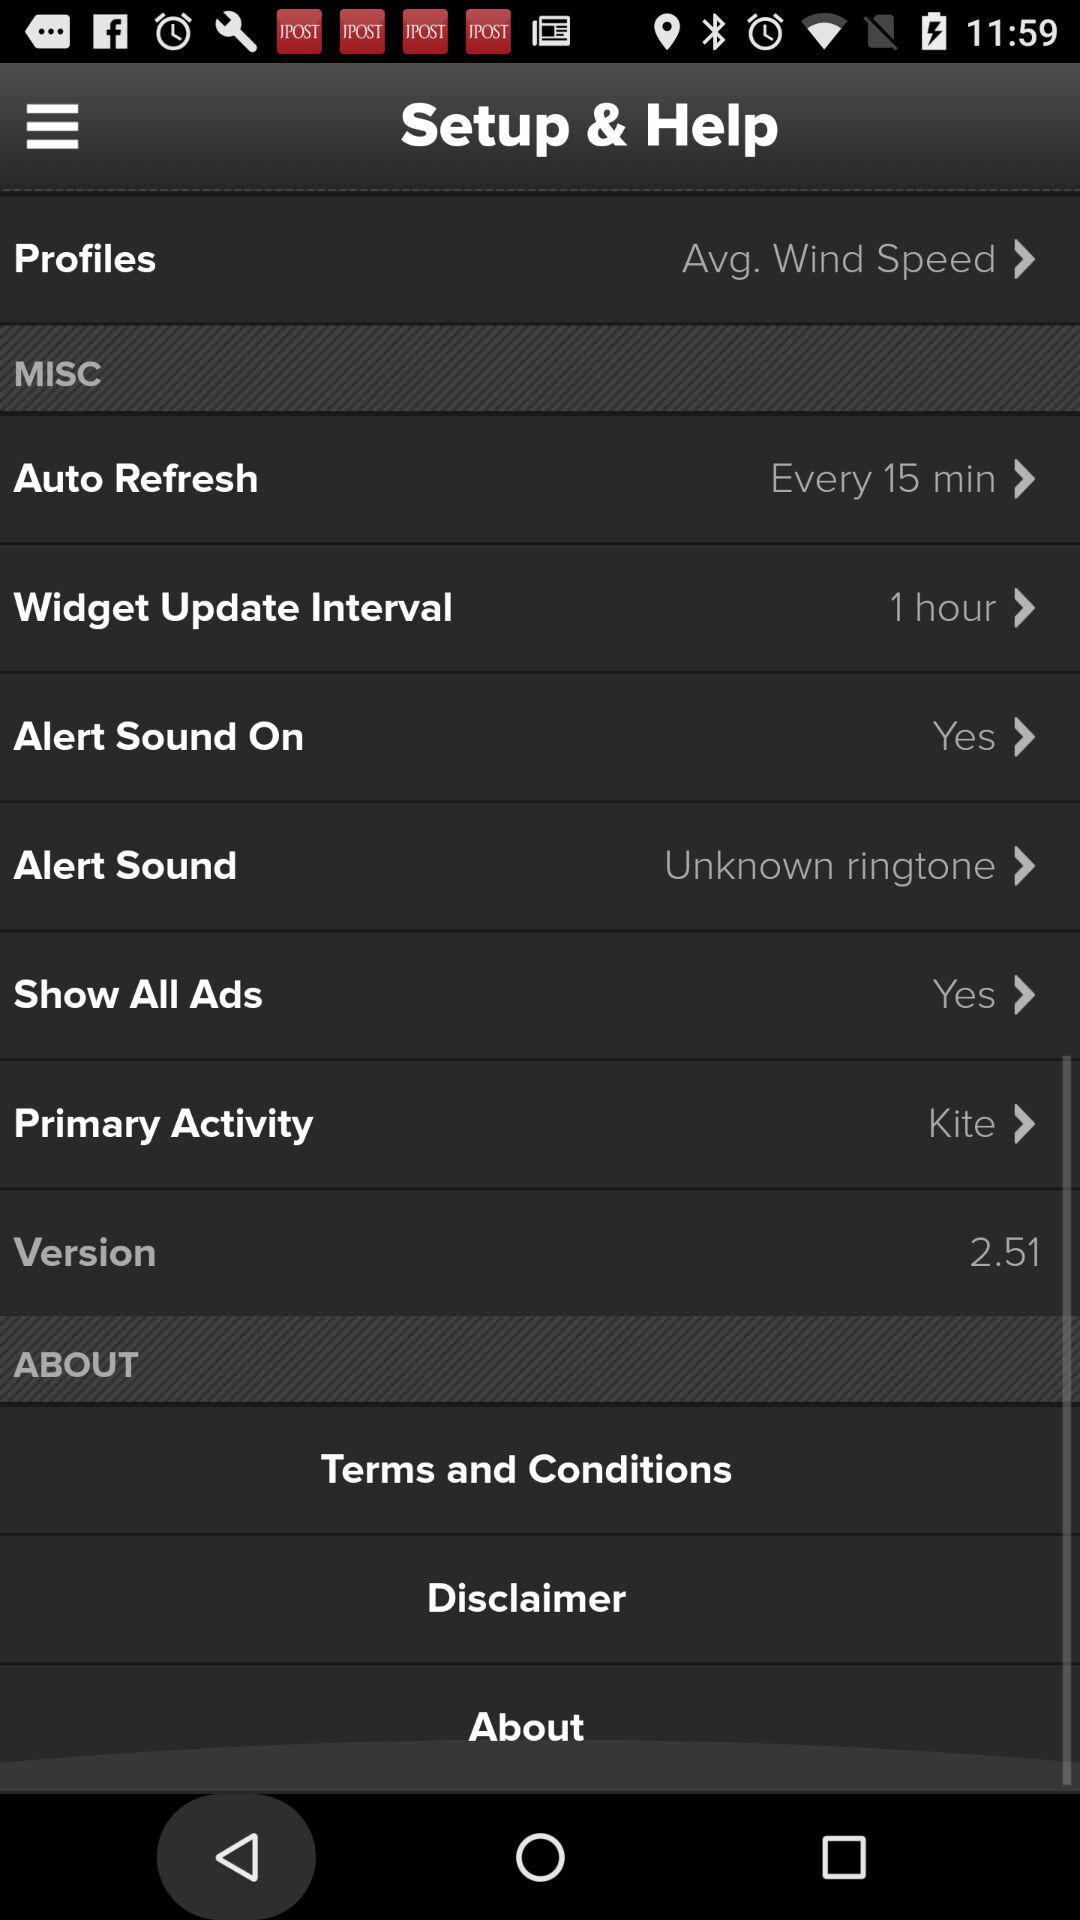How many items have a text value of "Yes"?
Answer the question using a single word or phrase. 2 